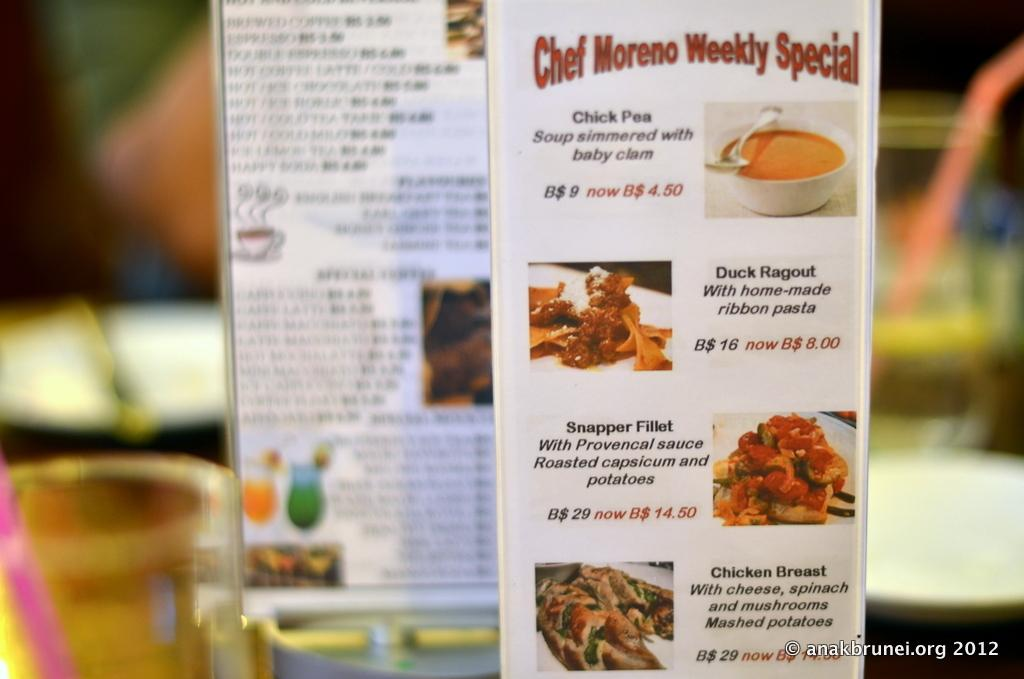<image>
Present a compact description of the photo's key features. A menu showing weekly specials including chick pea soup. 